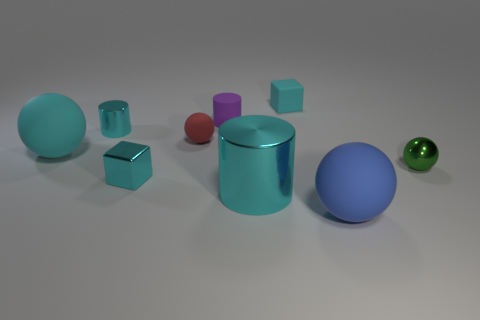Add 1 small green cylinders. How many objects exist? 10 Subtract all cubes. How many objects are left? 7 Subtract 0 brown spheres. How many objects are left? 9 Subtract all rubber cubes. Subtract all blue rubber things. How many objects are left? 7 Add 7 tiny cyan metal things. How many tiny cyan metal things are left? 9 Add 4 gray shiny things. How many gray shiny things exist? 4 